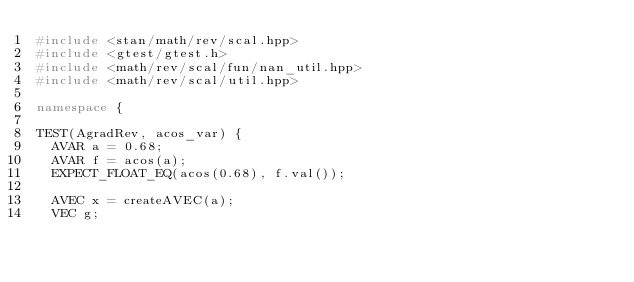Convert code to text. <code><loc_0><loc_0><loc_500><loc_500><_C++_>#include <stan/math/rev/scal.hpp>
#include <gtest/gtest.h>
#include <math/rev/scal/fun/nan_util.hpp>
#include <math/rev/scal/util.hpp>

namespace {

TEST(AgradRev, acos_var) {
  AVAR a = 0.68;
  AVAR f = acos(a);
  EXPECT_FLOAT_EQ(acos(0.68), f.val());

  AVEC x = createAVEC(a);
  VEC g;</code> 